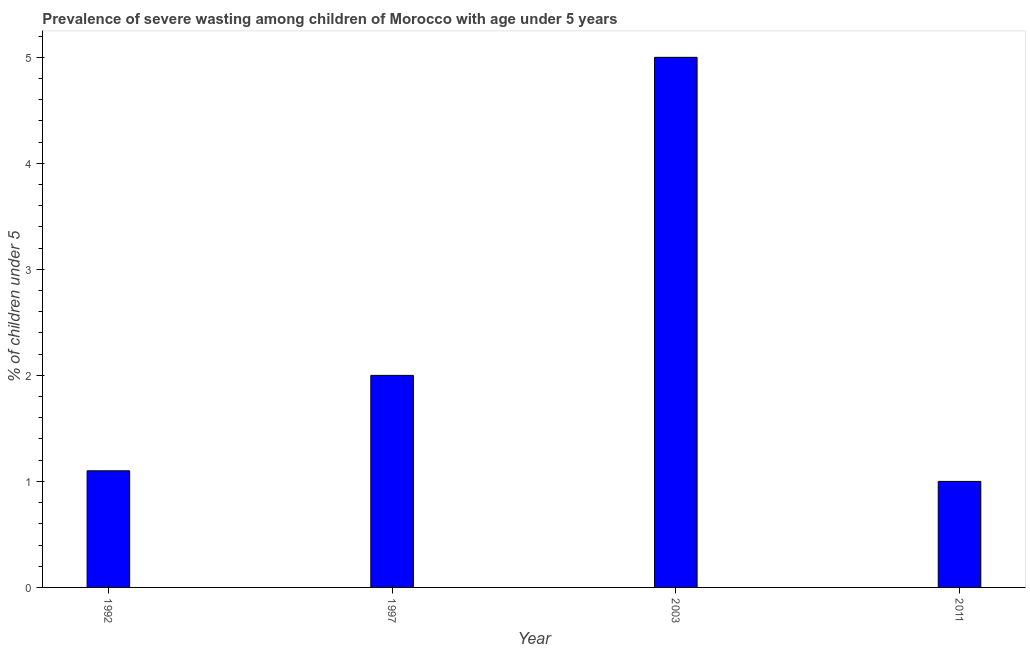Does the graph contain any zero values?
Provide a short and direct response. No. What is the title of the graph?
Provide a short and direct response. Prevalence of severe wasting among children of Morocco with age under 5 years. What is the label or title of the X-axis?
Offer a terse response. Year. What is the label or title of the Y-axis?
Keep it short and to the point.  % of children under 5. What is the prevalence of severe wasting in 1997?
Your answer should be very brief. 2. In which year was the prevalence of severe wasting maximum?
Keep it short and to the point. 2003. What is the sum of the prevalence of severe wasting?
Offer a terse response. 9.1. What is the difference between the prevalence of severe wasting in 1997 and 2011?
Keep it short and to the point. 1. What is the average prevalence of severe wasting per year?
Your response must be concise. 2.27. What is the median prevalence of severe wasting?
Ensure brevity in your answer.  1.55. In how many years, is the prevalence of severe wasting greater than 1.8 %?
Your response must be concise. 2. Do a majority of the years between 2011 and 1997 (inclusive) have prevalence of severe wasting greater than 0.6 %?
Make the answer very short. Yes. What is the ratio of the prevalence of severe wasting in 1992 to that in 2003?
Your answer should be compact. 0.22. Is the prevalence of severe wasting in 1992 less than that in 2003?
Provide a succinct answer. Yes. Is the difference between the prevalence of severe wasting in 2003 and 2011 greater than the difference between any two years?
Provide a short and direct response. Yes. What is the difference between the highest and the lowest prevalence of severe wasting?
Your answer should be very brief. 4. In how many years, is the prevalence of severe wasting greater than the average prevalence of severe wasting taken over all years?
Offer a terse response. 1. How many bars are there?
Your response must be concise. 4. What is the  % of children under 5 in 1992?
Your answer should be compact. 1.1. What is the  % of children under 5 in 2003?
Ensure brevity in your answer.  5. What is the  % of children under 5 in 2011?
Make the answer very short. 1. What is the difference between the  % of children under 5 in 1992 and 1997?
Keep it short and to the point. -0.9. What is the difference between the  % of children under 5 in 1992 and 2003?
Provide a short and direct response. -3.9. What is the difference between the  % of children under 5 in 1997 and 2003?
Your answer should be very brief. -3. What is the difference between the  % of children under 5 in 1997 and 2011?
Offer a very short reply. 1. What is the ratio of the  % of children under 5 in 1992 to that in 1997?
Provide a succinct answer. 0.55. What is the ratio of the  % of children under 5 in 1992 to that in 2003?
Give a very brief answer. 0.22. What is the ratio of the  % of children under 5 in 1992 to that in 2011?
Offer a terse response. 1.1. What is the ratio of the  % of children under 5 in 1997 to that in 2003?
Your answer should be very brief. 0.4. What is the ratio of the  % of children under 5 in 1997 to that in 2011?
Give a very brief answer. 2. 